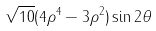Convert formula to latex. <formula><loc_0><loc_0><loc_500><loc_500>\sqrt { 1 0 } ( 4 \rho ^ { 4 } - 3 \rho ^ { 2 } ) \sin 2 \theta</formula> 